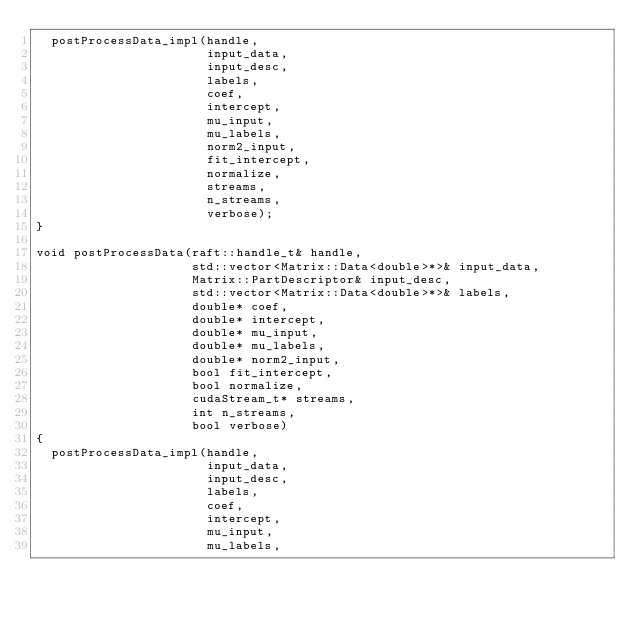<code> <loc_0><loc_0><loc_500><loc_500><_Cuda_>  postProcessData_impl(handle,
                       input_data,
                       input_desc,
                       labels,
                       coef,
                       intercept,
                       mu_input,
                       mu_labels,
                       norm2_input,
                       fit_intercept,
                       normalize,
                       streams,
                       n_streams,
                       verbose);
}

void postProcessData(raft::handle_t& handle,
                     std::vector<Matrix::Data<double>*>& input_data,
                     Matrix::PartDescriptor& input_desc,
                     std::vector<Matrix::Data<double>*>& labels,
                     double* coef,
                     double* intercept,
                     double* mu_input,
                     double* mu_labels,
                     double* norm2_input,
                     bool fit_intercept,
                     bool normalize,
                     cudaStream_t* streams,
                     int n_streams,
                     bool verbose)
{
  postProcessData_impl(handle,
                       input_data,
                       input_desc,
                       labels,
                       coef,
                       intercept,
                       mu_input,
                       mu_labels,</code> 